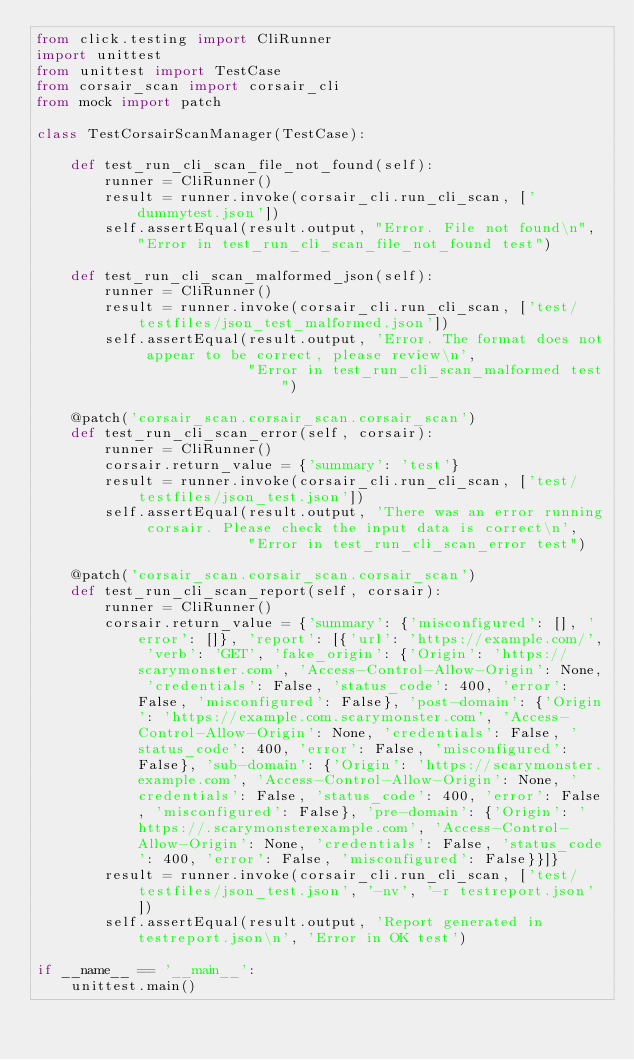Convert code to text. <code><loc_0><loc_0><loc_500><loc_500><_Python_>from click.testing import CliRunner
import unittest
from unittest import TestCase
from corsair_scan import corsair_cli
from mock import patch

class TestCorsairScanManager(TestCase):

    def test_run_cli_scan_file_not_found(self):
        runner = CliRunner()
        result = runner.invoke(corsair_cli.run_cli_scan, ['dummytest.json'])
        self.assertEqual(result.output, "Error. File not found\n", "Error in test_run_cli_scan_file_not_found test")

    def test_run_cli_scan_malformed_json(self):
        runner = CliRunner()
        result = runner.invoke(corsair_cli.run_cli_scan, ['test/testfiles/json_test_malformed.json'])
        self.assertEqual(result.output, 'Error. The format does not appear to be correct, please review\n',
                         "Error in test_run_cli_scan_malformed test")

    @patch('corsair_scan.corsair_scan.corsair_scan')
    def test_run_cli_scan_error(self, corsair):
        runner = CliRunner()
        corsair.return_value = {'summary': 'test'}
        result = runner.invoke(corsair_cli.run_cli_scan, ['test/testfiles/json_test.json'])
        self.assertEqual(result.output, 'There was an error running corsair. Please check the input data is correct\n',
                         "Error in test_run_cli_scan_error test")

    @patch('corsair_scan.corsair_scan.corsair_scan')
    def test_run_cli_scan_report(self, corsair):
        runner = CliRunner()
        corsair.return_value = {'summary': {'misconfigured': [], 'error': []}, 'report': [{'url': 'https://example.com/', 'verb': 'GET', 'fake_origin': {'Origin': 'https://scarymonster.com', 'Access-Control-Allow-Origin': None, 'credentials': False, 'status_code': 400, 'error': False, 'misconfigured': False}, 'post-domain': {'Origin': 'https://example.com.scarymonster.com', 'Access-Control-Allow-Origin': None, 'credentials': False, 'status_code': 400, 'error': False, 'misconfigured': False}, 'sub-domain': {'Origin': 'https://scarymonster.example.com', 'Access-Control-Allow-Origin': None, 'credentials': False, 'status_code': 400, 'error': False, 'misconfigured': False}, 'pre-domain': {'Origin': 'https://.scarymonsterexample.com', 'Access-Control-Allow-Origin': None, 'credentials': False, 'status_code': 400, 'error': False, 'misconfigured': False}}]}
        result = runner.invoke(corsair_cli.run_cli_scan, ['test/testfiles/json_test.json', '-nv', '-r testreport.json'])
        self.assertEqual(result.output, 'Report generated in  testreport.json\n', 'Error in OK test')

if __name__ == '__main__':
    unittest.main()


</code> 